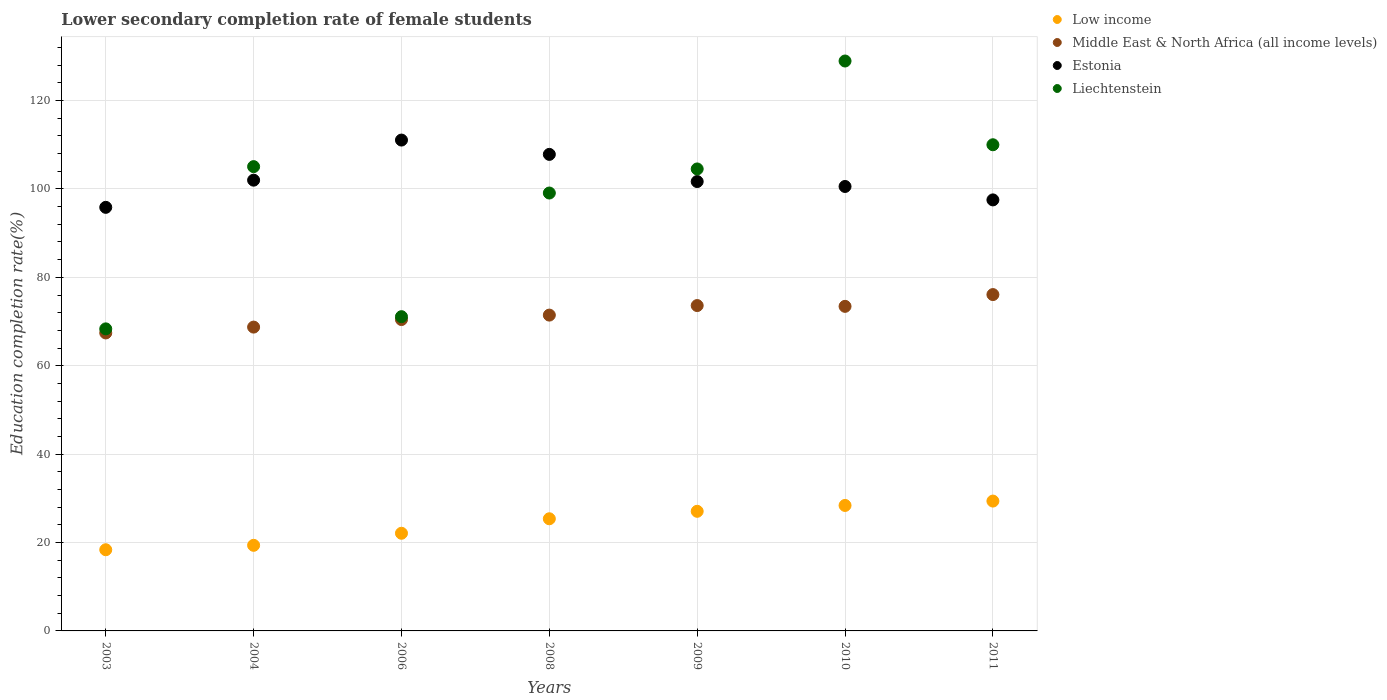Is the number of dotlines equal to the number of legend labels?
Make the answer very short. Yes. What is the lower secondary completion rate of female students in Middle East & North Africa (all income levels) in 2003?
Your response must be concise. 67.42. Across all years, what is the maximum lower secondary completion rate of female students in Liechtenstein?
Your answer should be compact. 128.95. Across all years, what is the minimum lower secondary completion rate of female students in Estonia?
Your answer should be compact. 95.84. In which year was the lower secondary completion rate of female students in Liechtenstein maximum?
Give a very brief answer. 2010. In which year was the lower secondary completion rate of female students in Liechtenstein minimum?
Keep it short and to the point. 2003. What is the total lower secondary completion rate of female students in Low income in the graph?
Provide a short and direct response. 170.04. What is the difference between the lower secondary completion rate of female students in Middle East & North Africa (all income levels) in 2006 and that in 2010?
Your response must be concise. -2.99. What is the difference between the lower secondary completion rate of female students in Low income in 2004 and the lower secondary completion rate of female students in Middle East & North Africa (all income levels) in 2008?
Provide a short and direct response. -52.09. What is the average lower secondary completion rate of female students in Liechtenstein per year?
Provide a short and direct response. 98.15. In the year 2006, what is the difference between the lower secondary completion rate of female students in Liechtenstein and lower secondary completion rate of female students in Middle East & North Africa (all income levels)?
Keep it short and to the point. 0.65. In how many years, is the lower secondary completion rate of female students in Middle East & North Africa (all income levels) greater than 56 %?
Provide a succinct answer. 7. What is the ratio of the lower secondary completion rate of female students in Liechtenstein in 2003 to that in 2010?
Provide a short and direct response. 0.53. What is the difference between the highest and the second highest lower secondary completion rate of female students in Low income?
Make the answer very short. 0.99. What is the difference between the highest and the lowest lower secondary completion rate of female students in Liechtenstein?
Offer a terse response. 60.61. Is it the case that in every year, the sum of the lower secondary completion rate of female students in Low income and lower secondary completion rate of female students in Middle East & North Africa (all income levels)  is greater than the sum of lower secondary completion rate of female students in Estonia and lower secondary completion rate of female students in Liechtenstein?
Offer a very short reply. No. Does the lower secondary completion rate of female students in Estonia monotonically increase over the years?
Your response must be concise. No. Is the lower secondary completion rate of female students in Estonia strictly greater than the lower secondary completion rate of female students in Low income over the years?
Provide a short and direct response. Yes. How many years are there in the graph?
Keep it short and to the point. 7. Does the graph contain any zero values?
Give a very brief answer. No. Does the graph contain grids?
Keep it short and to the point. Yes. How are the legend labels stacked?
Your answer should be very brief. Vertical. What is the title of the graph?
Provide a succinct answer. Lower secondary completion rate of female students. What is the label or title of the X-axis?
Make the answer very short. Years. What is the label or title of the Y-axis?
Your response must be concise. Education completion rate(%). What is the Education completion rate(%) in Low income in 2003?
Offer a terse response. 18.37. What is the Education completion rate(%) of Middle East & North Africa (all income levels) in 2003?
Offer a terse response. 67.42. What is the Education completion rate(%) in Estonia in 2003?
Your response must be concise. 95.84. What is the Education completion rate(%) in Liechtenstein in 2003?
Offer a terse response. 68.34. What is the Education completion rate(%) of Low income in 2004?
Offer a terse response. 19.37. What is the Education completion rate(%) of Middle East & North Africa (all income levels) in 2004?
Your answer should be compact. 68.74. What is the Education completion rate(%) of Estonia in 2004?
Offer a terse response. 101.99. What is the Education completion rate(%) of Liechtenstein in 2004?
Your answer should be compact. 105.05. What is the Education completion rate(%) in Low income in 2006?
Your response must be concise. 22.1. What is the Education completion rate(%) of Middle East & North Africa (all income levels) in 2006?
Provide a succinct answer. 70.45. What is the Education completion rate(%) in Estonia in 2006?
Your answer should be compact. 111.06. What is the Education completion rate(%) of Liechtenstein in 2006?
Offer a terse response. 71.1. What is the Education completion rate(%) in Low income in 2008?
Provide a short and direct response. 25.38. What is the Education completion rate(%) in Middle East & North Africa (all income levels) in 2008?
Provide a succinct answer. 71.46. What is the Education completion rate(%) of Estonia in 2008?
Ensure brevity in your answer.  107.82. What is the Education completion rate(%) of Liechtenstein in 2008?
Ensure brevity in your answer.  99.08. What is the Education completion rate(%) in Low income in 2009?
Provide a succinct answer. 27.06. What is the Education completion rate(%) in Middle East & North Africa (all income levels) in 2009?
Your answer should be compact. 73.62. What is the Education completion rate(%) of Estonia in 2009?
Ensure brevity in your answer.  101.68. What is the Education completion rate(%) of Liechtenstein in 2009?
Offer a very short reply. 104.52. What is the Education completion rate(%) of Low income in 2010?
Keep it short and to the point. 28.39. What is the Education completion rate(%) in Middle East & North Africa (all income levels) in 2010?
Your response must be concise. 73.44. What is the Education completion rate(%) in Estonia in 2010?
Provide a short and direct response. 100.56. What is the Education completion rate(%) of Liechtenstein in 2010?
Offer a terse response. 128.95. What is the Education completion rate(%) of Low income in 2011?
Give a very brief answer. 29.38. What is the Education completion rate(%) of Middle East & North Africa (all income levels) in 2011?
Offer a terse response. 76.1. What is the Education completion rate(%) of Estonia in 2011?
Keep it short and to the point. 97.52. What is the Education completion rate(%) in Liechtenstein in 2011?
Give a very brief answer. 110. Across all years, what is the maximum Education completion rate(%) of Low income?
Your response must be concise. 29.38. Across all years, what is the maximum Education completion rate(%) of Middle East & North Africa (all income levels)?
Offer a terse response. 76.1. Across all years, what is the maximum Education completion rate(%) in Estonia?
Provide a succinct answer. 111.06. Across all years, what is the maximum Education completion rate(%) in Liechtenstein?
Your response must be concise. 128.95. Across all years, what is the minimum Education completion rate(%) of Low income?
Offer a very short reply. 18.37. Across all years, what is the minimum Education completion rate(%) in Middle East & North Africa (all income levels)?
Your answer should be very brief. 67.42. Across all years, what is the minimum Education completion rate(%) of Estonia?
Your answer should be very brief. 95.84. Across all years, what is the minimum Education completion rate(%) of Liechtenstein?
Offer a very short reply. 68.34. What is the total Education completion rate(%) of Low income in the graph?
Offer a very short reply. 170.04. What is the total Education completion rate(%) of Middle East & North Africa (all income levels) in the graph?
Provide a succinct answer. 501.22. What is the total Education completion rate(%) of Estonia in the graph?
Your answer should be very brief. 716.47. What is the total Education completion rate(%) of Liechtenstein in the graph?
Offer a terse response. 687.04. What is the difference between the Education completion rate(%) in Low income in 2003 and that in 2004?
Provide a succinct answer. -1. What is the difference between the Education completion rate(%) in Middle East & North Africa (all income levels) in 2003 and that in 2004?
Give a very brief answer. -1.32. What is the difference between the Education completion rate(%) of Estonia in 2003 and that in 2004?
Offer a terse response. -6.15. What is the difference between the Education completion rate(%) in Liechtenstein in 2003 and that in 2004?
Provide a succinct answer. -36.71. What is the difference between the Education completion rate(%) in Low income in 2003 and that in 2006?
Your answer should be very brief. -3.73. What is the difference between the Education completion rate(%) in Middle East & North Africa (all income levels) in 2003 and that in 2006?
Give a very brief answer. -3.03. What is the difference between the Education completion rate(%) of Estonia in 2003 and that in 2006?
Offer a very short reply. -15.22. What is the difference between the Education completion rate(%) in Liechtenstein in 2003 and that in 2006?
Make the answer very short. -2.76. What is the difference between the Education completion rate(%) in Low income in 2003 and that in 2008?
Provide a short and direct response. -7.01. What is the difference between the Education completion rate(%) in Middle East & North Africa (all income levels) in 2003 and that in 2008?
Keep it short and to the point. -4.04. What is the difference between the Education completion rate(%) of Estonia in 2003 and that in 2008?
Offer a terse response. -11.98. What is the difference between the Education completion rate(%) of Liechtenstein in 2003 and that in 2008?
Keep it short and to the point. -30.74. What is the difference between the Education completion rate(%) in Low income in 2003 and that in 2009?
Make the answer very short. -8.7. What is the difference between the Education completion rate(%) of Middle East & North Africa (all income levels) in 2003 and that in 2009?
Give a very brief answer. -6.2. What is the difference between the Education completion rate(%) in Estonia in 2003 and that in 2009?
Offer a very short reply. -5.84. What is the difference between the Education completion rate(%) in Liechtenstein in 2003 and that in 2009?
Keep it short and to the point. -36.18. What is the difference between the Education completion rate(%) of Low income in 2003 and that in 2010?
Provide a succinct answer. -10.02. What is the difference between the Education completion rate(%) in Middle East & North Africa (all income levels) in 2003 and that in 2010?
Keep it short and to the point. -6.02. What is the difference between the Education completion rate(%) of Estonia in 2003 and that in 2010?
Offer a very short reply. -4.72. What is the difference between the Education completion rate(%) of Liechtenstein in 2003 and that in 2010?
Offer a terse response. -60.61. What is the difference between the Education completion rate(%) in Low income in 2003 and that in 2011?
Give a very brief answer. -11.01. What is the difference between the Education completion rate(%) of Middle East & North Africa (all income levels) in 2003 and that in 2011?
Your response must be concise. -8.68. What is the difference between the Education completion rate(%) in Estonia in 2003 and that in 2011?
Offer a terse response. -1.68. What is the difference between the Education completion rate(%) in Liechtenstein in 2003 and that in 2011?
Your answer should be compact. -41.66. What is the difference between the Education completion rate(%) of Low income in 2004 and that in 2006?
Your answer should be compact. -2.73. What is the difference between the Education completion rate(%) in Middle East & North Africa (all income levels) in 2004 and that in 2006?
Make the answer very short. -1.71. What is the difference between the Education completion rate(%) in Estonia in 2004 and that in 2006?
Give a very brief answer. -9.07. What is the difference between the Education completion rate(%) in Liechtenstein in 2004 and that in 2006?
Your answer should be very brief. 33.95. What is the difference between the Education completion rate(%) of Low income in 2004 and that in 2008?
Make the answer very short. -6.01. What is the difference between the Education completion rate(%) of Middle East & North Africa (all income levels) in 2004 and that in 2008?
Provide a succinct answer. -2.71. What is the difference between the Education completion rate(%) of Estonia in 2004 and that in 2008?
Provide a succinct answer. -5.84. What is the difference between the Education completion rate(%) of Liechtenstein in 2004 and that in 2008?
Your answer should be very brief. 5.97. What is the difference between the Education completion rate(%) in Low income in 2004 and that in 2009?
Ensure brevity in your answer.  -7.7. What is the difference between the Education completion rate(%) in Middle East & North Africa (all income levels) in 2004 and that in 2009?
Your answer should be compact. -4.87. What is the difference between the Education completion rate(%) of Estonia in 2004 and that in 2009?
Keep it short and to the point. 0.31. What is the difference between the Education completion rate(%) in Liechtenstein in 2004 and that in 2009?
Your answer should be very brief. 0.53. What is the difference between the Education completion rate(%) of Low income in 2004 and that in 2010?
Offer a very short reply. -9.02. What is the difference between the Education completion rate(%) of Middle East & North Africa (all income levels) in 2004 and that in 2010?
Offer a very short reply. -4.69. What is the difference between the Education completion rate(%) in Estonia in 2004 and that in 2010?
Offer a very short reply. 1.43. What is the difference between the Education completion rate(%) in Liechtenstein in 2004 and that in 2010?
Offer a very short reply. -23.9. What is the difference between the Education completion rate(%) in Low income in 2004 and that in 2011?
Make the answer very short. -10.01. What is the difference between the Education completion rate(%) of Middle East & North Africa (all income levels) in 2004 and that in 2011?
Give a very brief answer. -7.36. What is the difference between the Education completion rate(%) in Estonia in 2004 and that in 2011?
Offer a very short reply. 4.46. What is the difference between the Education completion rate(%) of Liechtenstein in 2004 and that in 2011?
Offer a very short reply. -4.95. What is the difference between the Education completion rate(%) of Low income in 2006 and that in 2008?
Keep it short and to the point. -3.28. What is the difference between the Education completion rate(%) in Middle East & North Africa (all income levels) in 2006 and that in 2008?
Give a very brief answer. -1.01. What is the difference between the Education completion rate(%) of Estonia in 2006 and that in 2008?
Your answer should be compact. 3.24. What is the difference between the Education completion rate(%) of Liechtenstein in 2006 and that in 2008?
Provide a succinct answer. -27.98. What is the difference between the Education completion rate(%) of Low income in 2006 and that in 2009?
Give a very brief answer. -4.97. What is the difference between the Education completion rate(%) in Middle East & North Africa (all income levels) in 2006 and that in 2009?
Your answer should be compact. -3.17. What is the difference between the Education completion rate(%) in Estonia in 2006 and that in 2009?
Make the answer very short. 9.39. What is the difference between the Education completion rate(%) of Liechtenstein in 2006 and that in 2009?
Your response must be concise. -33.42. What is the difference between the Education completion rate(%) in Low income in 2006 and that in 2010?
Offer a terse response. -6.29. What is the difference between the Education completion rate(%) in Middle East & North Africa (all income levels) in 2006 and that in 2010?
Make the answer very short. -2.99. What is the difference between the Education completion rate(%) in Estonia in 2006 and that in 2010?
Your response must be concise. 10.5. What is the difference between the Education completion rate(%) in Liechtenstein in 2006 and that in 2010?
Make the answer very short. -57.85. What is the difference between the Education completion rate(%) of Low income in 2006 and that in 2011?
Make the answer very short. -7.28. What is the difference between the Education completion rate(%) in Middle East & North Africa (all income levels) in 2006 and that in 2011?
Provide a short and direct response. -5.65. What is the difference between the Education completion rate(%) of Estonia in 2006 and that in 2011?
Offer a very short reply. 13.54. What is the difference between the Education completion rate(%) in Liechtenstein in 2006 and that in 2011?
Offer a terse response. -38.9. What is the difference between the Education completion rate(%) in Low income in 2008 and that in 2009?
Give a very brief answer. -1.69. What is the difference between the Education completion rate(%) of Middle East & North Africa (all income levels) in 2008 and that in 2009?
Keep it short and to the point. -2.16. What is the difference between the Education completion rate(%) of Estonia in 2008 and that in 2009?
Give a very brief answer. 6.15. What is the difference between the Education completion rate(%) in Liechtenstein in 2008 and that in 2009?
Provide a succinct answer. -5.45. What is the difference between the Education completion rate(%) of Low income in 2008 and that in 2010?
Your answer should be very brief. -3.01. What is the difference between the Education completion rate(%) in Middle East & North Africa (all income levels) in 2008 and that in 2010?
Your response must be concise. -1.98. What is the difference between the Education completion rate(%) in Estonia in 2008 and that in 2010?
Provide a succinct answer. 7.26. What is the difference between the Education completion rate(%) of Liechtenstein in 2008 and that in 2010?
Give a very brief answer. -29.87. What is the difference between the Education completion rate(%) of Low income in 2008 and that in 2011?
Make the answer very short. -4. What is the difference between the Education completion rate(%) of Middle East & North Africa (all income levels) in 2008 and that in 2011?
Keep it short and to the point. -4.64. What is the difference between the Education completion rate(%) in Estonia in 2008 and that in 2011?
Provide a succinct answer. 10.3. What is the difference between the Education completion rate(%) of Liechtenstein in 2008 and that in 2011?
Ensure brevity in your answer.  -10.92. What is the difference between the Education completion rate(%) in Low income in 2009 and that in 2010?
Your answer should be very brief. -1.33. What is the difference between the Education completion rate(%) in Middle East & North Africa (all income levels) in 2009 and that in 2010?
Give a very brief answer. 0.18. What is the difference between the Education completion rate(%) of Estonia in 2009 and that in 2010?
Give a very brief answer. 1.12. What is the difference between the Education completion rate(%) of Liechtenstein in 2009 and that in 2010?
Keep it short and to the point. -24.42. What is the difference between the Education completion rate(%) in Low income in 2009 and that in 2011?
Your response must be concise. -2.31. What is the difference between the Education completion rate(%) of Middle East & North Africa (all income levels) in 2009 and that in 2011?
Offer a terse response. -2.48. What is the difference between the Education completion rate(%) of Estonia in 2009 and that in 2011?
Your answer should be compact. 4.15. What is the difference between the Education completion rate(%) of Liechtenstein in 2009 and that in 2011?
Your response must be concise. -5.48. What is the difference between the Education completion rate(%) of Low income in 2010 and that in 2011?
Your answer should be very brief. -0.99. What is the difference between the Education completion rate(%) in Middle East & North Africa (all income levels) in 2010 and that in 2011?
Keep it short and to the point. -2.66. What is the difference between the Education completion rate(%) of Estonia in 2010 and that in 2011?
Give a very brief answer. 3.04. What is the difference between the Education completion rate(%) in Liechtenstein in 2010 and that in 2011?
Give a very brief answer. 18.95. What is the difference between the Education completion rate(%) in Low income in 2003 and the Education completion rate(%) in Middle East & North Africa (all income levels) in 2004?
Offer a terse response. -50.37. What is the difference between the Education completion rate(%) of Low income in 2003 and the Education completion rate(%) of Estonia in 2004?
Your response must be concise. -83.62. What is the difference between the Education completion rate(%) of Low income in 2003 and the Education completion rate(%) of Liechtenstein in 2004?
Keep it short and to the point. -86.68. What is the difference between the Education completion rate(%) in Middle East & North Africa (all income levels) in 2003 and the Education completion rate(%) in Estonia in 2004?
Ensure brevity in your answer.  -34.57. What is the difference between the Education completion rate(%) in Middle East & North Africa (all income levels) in 2003 and the Education completion rate(%) in Liechtenstein in 2004?
Your response must be concise. -37.63. What is the difference between the Education completion rate(%) of Estonia in 2003 and the Education completion rate(%) of Liechtenstein in 2004?
Offer a terse response. -9.21. What is the difference between the Education completion rate(%) of Low income in 2003 and the Education completion rate(%) of Middle East & North Africa (all income levels) in 2006?
Your response must be concise. -52.08. What is the difference between the Education completion rate(%) of Low income in 2003 and the Education completion rate(%) of Estonia in 2006?
Your answer should be compact. -92.69. What is the difference between the Education completion rate(%) in Low income in 2003 and the Education completion rate(%) in Liechtenstein in 2006?
Provide a succinct answer. -52.73. What is the difference between the Education completion rate(%) in Middle East & North Africa (all income levels) in 2003 and the Education completion rate(%) in Estonia in 2006?
Ensure brevity in your answer.  -43.64. What is the difference between the Education completion rate(%) in Middle East & North Africa (all income levels) in 2003 and the Education completion rate(%) in Liechtenstein in 2006?
Make the answer very short. -3.68. What is the difference between the Education completion rate(%) of Estonia in 2003 and the Education completion rate(%) of Liechtenstein in 2006?
Your response must be concise. 24.74. What is the difference between the Education completion rate(%) in Low income in 2003 and the Education completion rate(%) in Middle East & North Africa (all income levels) in 2008?
Offer a terse response. -53.09. What is the difference between the Education completion rate(%) of Low income in 2003 and the Education completion rate(%) of Estonia in 2008?
Keep it short and to the point. -89.45. What is the difference between the Education completion rate(%) in Low income in 2003 and the Education completion rate(%) in Liechtenstein in 2008?
Offer a very short reply. -80.71. What is the difference between the Education completion rate(%) of Middle East & North Africa (all income levels) in 2003 and the Education completion rate(%) of Estonia in 2008?
Your answer should be compact. -40.4. What is the difference between the Education completion rate(%) in Middle East & North Africa (all income levels) in 2003 and the Education completion rate(%) in Liechtenstein in 2008?
Offer a very short reply. -31.66. What is the difference between the Education completion rate(%) of Estonia in 2003 and the Education completion rate(%) of Liechtenstein in 2008?
Give a very brief answer. -3.24. What is the difference between the Education completion rate(%) of Low income in 2003 and the Education completion rate(%) of Middle East & North Africa (all income levels) in 2009?
Ensure brevity in your answer.  -55.25. What is the difference between the Education completion rate(%) in Low income in 2003 and the Education completion rate(%) in Estonia in 2009?
Make the answer very short. -83.31. What is the difference between the Education completion rate(%) in Low income in 2003 and the Education completion rate(%) in Liechtenstein in 2009?
Give a very brief answer. -86.16. What is the difference between the Education completion rate(%) of Middle East & North Africa (all income levels) in 2003 and the Education completion rate(%) of Estonia in 2009?
Offer a terse response. -34.26. What is the difference between the Education completion rate(%) of Middle East & North Africa (all income levels) in 2003 and the Education completion rate(%) of Liechtenstein in 2009?
Provide a short and direct response. -37.11. What is the difference between the Education completion rate(%) of Estonia in 2003 and the Education completion rate(%) of Liechtenstein in 2009?
Provide a short and direct response. -8.69. What is the difference between the Education completion rate(%) of Low income in 2003 and the Education completion rate(%) of Middle East & North Africa (all income levels) in 2010?
Offer a very short reply. -55.07. What is the difference between the Education completion rate(%) of Low income in 2003 and the Education completion rate(%) of Estonia in 2010?
Make the answer very short. -82.19. What is the difference between the Education completion rate(%) in Low income in 2003 and the Education completion rate(%) in Liechtenstein in 2010?
Your response must be concise. -110.58. What is the difference between the Education completion rate(%) of Middle East & North Africa (all income levels) in 2003 and the Education completion rate(%) of Estonia in 2010?
Your answer should be compact. -33.14. What is the difference between the Education completion rate(%) in Middle East & North Africa (all income levels) in 2003 and the Education completion rate(%) in Liechtenstein in 2010?
Offer a very short reply. -61.53. What is the difference between the Education completion rate(%) in Estonia in 2003 and the Education completion rate(%) in Liechtenstein in 2010?
Offer a terse response. -33.11. What is the difference between the Education completion rate(%) of Low income in 2003 and the Education completion rate(%) of Middle East & North Africa (all income levels) in 2011?
Give a very brief answer. -57.73. What is the difference between the Education completion rate(%) in Low income in 2003 and the Education completion rate(%) in Estonia in 2011?
Keep it short and to the point. -79.15. What is the difference between the Education completion rate(%) in Low income in 2003 and the Education completion rate(%) in Liechtenstein in 2011?
Offer a very short reply. -91.63. What is the difference between the Education completion rate(%) of Middle East & North Africa (all income levels) in 2003 and the Education completion rate(%) of Estonia in 2011?
Provide a succinct answer. -30.1. What is the difference between the Education completion rate(%) in Middle East & North Africa (all income levels) in 2003 and the Education completion rate(%) in Liechtenstein in 2011?
Offer a terse response. -42.58. What is the difference between the Education completion rate(%) in Estonia in 2003 and the Education completion rate(%) in Liechtenstein in 2011?
Your response must be concise. -14.16. What is the difference between the Education completion rate(%) in Low income in 2004 and the Education completion rate(%) in Middle East & North Africa (all income levels) in 2006?
Make the answer very short. -51.08. What is the difference between the Education completion rate(%) in Low income in 2004 and the Education completion rate(%) in Estonia in 2006?
Offer a very short reply. -91.69. What is the difference between the Education completion rate(%) in Low income in 2004 and the Education completion rate(%) in Liechtenstein in 2006?
Provide a short and direct response. -51.73. What is the difference between the Education completion rate(%) of Middle East & North Africa (all income levels) in 2004 and the Education completion rate(%) of Estonia in 2006?
Provide a short and direct response. -42.32. What is the difference between the Education completion rate(%) in Middle East & North Africa (all income levels) in 2004 and the Education completion rate(%) in Liechtenstein in 2006?
Provide a short and direct response. -2.36. What is the difference between the Education completion rate(%) of Estonia in 2004 and the Education completion rate(%) of Liechtenstein in 2006?
Keep it short and to the point. 30.89. What is the difference between the Education completion rate(%) of Low income in 2004 and the Education completion rate(%) of Middle East & North Africa (all income levels) in 2008?
Your answer should be compact. -52.09. What is the difference between the Education completion rate(%) in Low income in 2004 and the Education completion rate(%) in Estonia in 2008?
Ensure brevity in your answer.  -88.45. What is the difference between the Education completion rate(%) of Low income in 2004 and the Education completion rate(%) of Liechtenstein in 2008?
Give a very brief answer. -79.71. What is the difference between the Education completion rate(%) of Middle East & North Africa (all income levels) in 2004 and the Education completion rate(%) of Estonia in 2008?
Your response must be concise. -39.08. What is the difference between the Education completion rate(%) of Middle East & North Africa (all income levels) in 2004 and the Education completion rate(%) of Liechtenstein in 2008?
Provide a short and direct response. -30.34. What is the difference between the Education completion rate(%) in Estonia in 2004 and the Education completion rate(%) in Liechtenstein in 2008?
Provide a short and direct response. 2.91. What is the difference between the Education completion rate(%) of Low income in 2004 and the Education completion rate(%) of Middle East & North Africa (all income levels) in 2009?
Ensure brevity in your answer.  -54.25. What is the difference between the Education completion rate(%) in Low income in 2004 and the Education completion rate(%) in Estonia in 2009?
Your answer should be compact. -82.31. What is the difference between the Education completion rate(%) of Low income in 2004 and the Education completion rate(%) of Liechtenstein in 2009?
Provide a short and direct response. -85.16. What is the difference between the Education completion rate(%) of Middle East & North Africa (all income levels) in 2004 and the Education completion rate(%) of Estonia in 2009?
Offer a very short reply. -32.93. What is the difference between the Education completion rate(%) in Middle East & North Africa (all income levels) in 2004 and the Education completion rate(%) in Liechtenstein in 2009?
Ensure brevity in your answer.  -35.78. What is the difference between the Education completion rate(%) of Estonia in 2004 and the Education completion rate(%) of Liechtenstein in 2009?
Make the answer very short. -2.54. What is the difference between the Education completion rate(%) in Low income in 2004 and the Education completion rate(%) in Middle East & North Africa (all income levels) in 2010?
Provide a succinct answer. -54.07. What is the difference between the Education completion rate(%) of Low income in 2004 and the Education completion rate(%) of Estonia in 2010?
Your answer should be very brief. -81.19. What is the difference between the Education completion rate(%) of Low income in 2004 and the Education completion rate(%) of Liechtenstein in 2010?
Your response must be concise. -109.58. What is the difference between the Education completion rate(%) of Middle East & North Africa (all income levels) in 2004 and the Education completion rate(%) of Estonia in 2010?
Make the answer very short. -31.82. What is the difference between the Education completion rate(%) of Middle East & North Africa (all income levels) in 2004 and the Education completion rate(%) of Liechtenstein in 2010?
Your response must be concise. -60.21. What is the difference between the Education completion rate(%) of Estonia in 2004 and the Education completion rate(%) of Liechtenstein in 2010?
Provide a short and direct response. -26.96. What is the difference between the Education completion rate(%) of Low income in 2004 and the Education completion rate(%) of Middle East & North Africa (all income levels) in 2011?
Offer a very short reply. -56.73. What is the difference between the Education completion rate(%) in Low income in 2004 and the Education completion rate(%) in Estonia in 2011?
Keep it short and to the point. -78.15. What is the difference between the Education completion rate(%) of Low income in 2004 and the Education completion rate(%) of Liechtenstein in 2011?
Your answer should be compact. -90.63. What is the difference between the Education completion rate(%) of Middle East & North Africa (all income levels) in 2004 and the Education completion rate(%) of Estonia in 2011?
Provide a succinct answer. -28.78. What is the difference between the Education completion rate(%) of Middle East & North Africa (all income levels) in 2004 and the Education completion rate(%) of Liechtenstein in 2011?
Your answer should be compact. -41.26. What is the difference between the Education completion rate(%) in Estonia in 2004 and the Education completion rate(%) in Liechtenstein in 2011?
Make the answer very short. -8.01. What is the difference between the Education completion rate(%) in Low income in 2006 and the Education completion rate(%) in Middle East & North Africa (all income levels) in 2008?
Offer a very short reply. -49.36. What is the difference between the Education completion rate(%) in Low income in 2006 and the Education completion rate(%) in Estonia in 2008?
Your response must be concise. -85.73. What is the difference between the Education completion rate(%) in Low income in 2006 and the Education completion rate(%) in Liechtenstein in 2008?
Offer a terse response. -76.98. What is the difference between the Education completion rate(%) in Middle East & North Africa (all income levels) in 2006 and the Education completion rate(%) in Estonia in 2008?
Provide a succinct answer. -37.37. What is the difference between the Education completion rate(%) in Middle East & North Africa (all income levels) in 2006 and the Education completion rate(%) in Liechtenstein in 2008?
Your answer should be compact. -28.63. What is the difference between the Education completion rate(%) of Estonia in 2006 and the Education completion rate(%) of Liechtenstein in 2008?
Keep it short and to the point. 11.98. What is the difference between the Education completion rate(%) of Low income in 2006 and the Education completion rate(%) of Middle East & North Africa (all income levels) in 2009?
Your answer should be very brief. -51.52. What is the difference between the Education completion rate(%) in Low income in 2006 and the Education completion rate(%) in Estonia in 2009?
Your response must be concise. -79.58. What is the difference between the Education completion rate(%) of Low income in 2006 and the Education completion rate(%) of Liechtenstein in 2009?
Your answer should be very brief. -82.43. What is the difference between the Education completion rate(%) of Middle East & North Africa (all income levels) in 2006 and the Education completion rate(%) of Estonia in 2009?
Make the answer very short. -31.23. What is the difference between the Education completion rate(%) in Middle East & North Africa (all income levels) in 2006 and the Education completion rate(%) in Liechtenstein in 2009?
Offer a terse response. -34.07. What is the difference between the Education completion rate(%) in Estonia in 2006 and the Education completion rate(%) in Liechtenstein in 2009?
Offer a very short reply. 6.54. What is the difference between the Education completion rate(%) of Low income in 2006 and the Education completion rate(%) of Middle East & North Africa (all income levels) in 2010?
Provide a succinct answer. -51.34. What is the difference between the Education completion rate(%) in Low income in 2006 and the Education completion rate(%) in Estonia in 2010?
Ensure brevity in your answer.  -78.46. What is the difference between the Education completion rate(%) of Low income in 2006 and the Education completion rate(%) of Liechtenstein in 2010?
Ensure brevity in your answer.  -106.85. What is the difference between the Education completion rate(%) of Middle East & North Africa (all income levels) in 2006 and the Education completion rate(%) of Estonia in 2010?
Give a very brief answer. -30.11. What is the difference between the Education completion rate(%) of Middle East & North Africa (all income levels) in 2006 and the Education completion rate(%) of Liechtenstein in 2010?
Offer a terse response. -58.5. What is the difference between the Education completion rate(%) of Estonia in 2006 and the Education completion rate(%) of Liechtenstein in 2010?
Keep it short and to the point. -17.89. What is the difference between the Education completion rate(%) in Low income in 2006 and the Education completion rate(%) in Middle East & North Africa (all income levels) in 2011?
Make the answer very short. -54. What is the difference between the Education completion rate(%) in Low income in 2006 and the Education completion rate(%) in Estonia in 2011?
Your answer should be very brief. -75.43. What is the difference between the Education completion rate(%) of Low income in 2006 and the Education completion rate(%) of Liechtenstein in 2011?
Offer a very short reply. -87.9. What is the difference between the Education completion rate(%) of Middle East & North Africa (all income levels) in 2006 and the Education completion rate(%) of Estonia in 2011?
Offer a terse response. -27.07. What is the difference between the Education completion rate(%) of Middle East & North Africa (all income levels) in 2006 and the Education completion rate(%) of Liechtenstein in 2011?
Keep it short and to the point. -39.55. What is the difference between the Education completion rate(%) in Estonia in 2006 and the Education completion rate(%) in Liechtenstein in 2011?
Ensure brevity in your answer.  1.06. What is the difference between the Education completion rate(%) of Low income in 2008 and the Education completion rate(%) of Middle East & North Africa (all income levels) in 2009?
Offer a very short reply. -48.24. What is the difference between the Education completion rate(%) in Low income in 2008 and the Education completion rate(%) in Estonia in 2009?
Keep it short and to the point. -76.3. What is the difference between the Education completion rate(%) of Low income in 2008 and the Education completion rate(%) of Liechtenstein in 2009?
Keep it short and to the point. -79.15. What is the difference between the Education completion rate(%) of Middle East & North Africa (all income levels) in 2008 and the Education completion rate(%) of Estonia in 2009?
Your answer should be very brief. -30.22. What is the difference between the Education completion rate(%) of Middle East & North Africa (all income levels) in 2008 and the Education completion rate(%) of Liechtenstein in 2009?
Your response must be concise. -33.07. What is the difference between the Education completion rate(%) of Estonia in 2008 and the Education completion rate(%) of Liechtenstein in 2009?
Your answer should be very brief. 3.3. What is the difference between the Education completion rate(%) in Low income in 2008 and the Education completion rate(%) in Middle East & North Africa (all income levels) in 2010?
Provide a short and direct response. -48.06. What is the difference between the Education completion rate(%) of Low income in 2008 and the Education completion rate(%) of Estonia in 2010?
Your answer should be compact. -75.18. What is the difference between the Education completion rate(%) in Low income in 2008 and the Education completion rate(%) in Liechtenstein in 2010?
Your answer should be compact. -103.57. What is the difference between the Education completion rate(%) of Middle East & North Africa (all income levels) in 2008 and the Education completion rate(%) of Estonia in 2010?
Provide a short and direct response. -29.1. What is the difference between the Education completion rate(%) of Middle East & North Africa (all income levels) in 2008 and the Education completion rate(%) of Liechtenstein in 2010?
Provide a short and direct response. -57.49. What is the difference between the Education completion rate(%) in Estonia in 2008 and the Education completion rate(%) in Liechtenstein in 2010?
Provide a short and direct response. -21.13. What is the difference between the Education completion rate(%) in Low income in 2008 and the Education completion rate(%) in Middle East & North Africa (all income levels) in 2011?
Provide a short and direct response. -50.72. What is the difference between the Education completion rate(%) in Low income in 2008 and the Education completion rate(%) in Estonia in 2011?
Your response must be concise. -72.15. What is the difference between the Education completion rate(%) of Low income in 2008 and the Education completion rate(%) of Liechtenstein in 2011?
Offer a terse response. -84.62. What is the difference between the Education completion rate(%) in Middle East & North Africa (all income levels) in 2008 and the Education completion rate(%) in Estonia in 2011?
Offer a very short reply. -26.07. What is the difference between the Education completion rate(%) in Middle East & North Africa (all income levels) in 2008 and the Education completion rate(%) in Liechtenstein in 2011?
Your response must be concise. -38.54. What is the difference between the Education completion rate(%) of Estonia in 2008 and the Education completion rate(%) of Liechtenstein in 2011?
Provide a short and direct response. -2.18. What is the difference between the Education completion rate(%) of Low income in 2009 and the Education completion rate(%) of Middle East & North Africa (all income levels) in 2010?
Make the answer very short. -46.37. What is the difference between the Education completion rate(%) in Low income in 2009 and the Education completion rate(%) in Estonia in 2010?
Offer a terse response. -73.5. What is the difference between the Education completion rate(%) in Low income in 2009 and the Education completion rate(%) in Liechtenstein in 2010?
Provide a succinct answer. -101.88. What is the difference between the Education completion rate(%) in Middle East & North Africa (all income levels) in 2009 and the Education completion rate(%) in Estonia in 2010?
Your response must be concise. -26.94. What is the difference between the Education completion rate(%) in Middle East & North Africa (all income levels) in 2009 and the Education completion rate(%) in Liechtenstein in 2010?
Provide a short and direct response. -55.33. What is the difference between the Education completion rate(%) in Estonia in 2009 and the Education completion rate(%) in Liechtenstein in 2010?
Keep it short and to the point. -27.27. What is the difference between the Education completion rate(%) of Low income in 2009 and the Education completion rate(%) of Middle East & North Africa (all income levels) in 2011?
Make the answer very short. -49.04. What is the difference between the Education completion rate(%) in Low income in 2009 and the Education completion rate(%) in Estonia in 2011?
Your answer should be very brief. -70.46. What is the difference between the Education completion rate(%) of Low income in 2009 and the Education completion rate(%) of Liechtenstein in 2011?
Ensure brevity in your answer.  -82.94. What is the difference between the Education completion rate(%) of Middle East & North Africa (all income levels) in 2009 and the Education completion rate(%) of Estonia in 2011?
Make the answer very short. -23.91. What is the difference between the Education completion rate(%) of Middle East & North Africa (all income levels) in 2009 and the Education completion rate(%) of Liechtenstein in 2011?
Your response must be concise. -36.38. What is the difference between the Education completion rate(%) of Estonia in 2009 and the Education completion rate(%) of Liechtenstein in 2011?
Offer a terse response. -8.32. What is the difference between the Education completion rate(%) in Low income in 2010 and the Education completion rate(%) in Middle East & North Africa (all income levels) in 2011?
Make the answer very short. -47.71. What is the difference between the Education completion rate(%) of Low income in 2010 and the Education completion rate(%) of Estonia in 2011?
Keep it short and to the point. -69.13. What is the difference between the Education completion rate(%) in Low income in 2010 and the Education completion rate(%) in Liechtenstein in 2011?
Your answer should be very brief. -81.61. What is the difference between the Education completion rate(%) of Middle East & North Africa (all income levels) in 2010 and the Education completion rate(%) of Estonia in 2011?
Make the answer very short. -24.09. What is the difference between the Education completion rate(%) in Middle East & North Africa (all income levels) in 2010 and the Education completion rate(%) in Liechtenstein in 2011?
Provide a short and direct response. -36.56. What is the difference between the Education completion rate(%) in Estonia in 2010 and the Education completion rate(%) in Liechtenstein in 2011?
Your response must be concise. -9.44. What is the average Education completion rate(%) in Low income per year?
Offer a terse response. 24.29. What is the average Education completion rate(%) in Middle East & North Africa (all income levels) per year?
Keep it short and to the point. 71.6. What is the average Education completion rate(%) in Estonia per year?
Provide a succinct answer. 102.35. What is the average Education completion rate(%) in Liechtenstein per year?
Give a very brief answer. 98.15. In the year 2003, what is the difference between the Education completion rate(%) in Low income and Education completion rate(%) in Middle East & North Africa (all income levels)?
Provide a short and direct response. -49.05. In the year 2003, what is the difference between the Education completion rate(%) in Low income and Education completion rate(%) in Estonia?
Keep it short and to the point. -77.47. In the year 2003, what is the difference between the Education completion rate(%) of Low income and Education completion rate(%) of Liechtenstein?
Offer a very short reply. -49.97. In the year 2003, what is the difference between the Education completion rate(%) in Middle East & North Africa (all income levels) and Education completion rate(%) in Estonia?
Provide a short and direct response. -28.42. In the year 2003, what is the difference between the Education completion rate(%) of Middle East & North Africa (all income levels) and Education completion rate(%) of Liechtenstein?
Make the answer very short. -0.92. In the year 2003, what is the difference between the Education completion rate(%) of Estonia and Education completion rate(%) of Liechtenstein?
Provide a short and direct response. 27.5. In the year 2004, what is the difference between the Education completion rate(%) of Low income and Education completion rate(%) of Middle East & North Africa (all income levels)?
Offer a very short reply. -49.37. In the year 2004, what is the difference between the Education completion rate(%) in Low income and Education completion rate(%) in Estonia?
Your answer should be very brief. -82.62. In the year 2004, what is the difference between the Education completion rate(%) in Low income and Education completion rate(%) in Liechtenstein?
Make the answer very short. -85.68. In the year 2004, what is the difference between the Education completion rate(%) in Middle East & North Africa (all income levels) and Education completion rate(%) in Estonia?
Your response must be concise. -33.24. In the year 2004, what is the difference between the Education completion rate(%) of Middle East & North Africa (all income levels) and Education completion rate(%) of Liechtenstein?
Keep it short and to the point. -36.31. In the year 2004, what is the difference between the Education completion rate(%) in Estonia and Education completion rate(%) in Liechtenstein?
Make the answer very short. -3.06. In the year 2006, what is the difference between the Education completion rate(%) of Low income and Education completion rate(%) of Middle East & North Africa (all income levels)?
Give a very brief answer. -48.35. In the year 2006, what is the difference between the Education completion rate(%) in Low income and Education completion rate(%) in Estonia?
Your answer should be very brief. -88.96. In the year 2006, what is the difference between the Education completion rate(%) in Low income and Education completion rate(%) in Liechtenstein?
Your answer should be compact. -49. In the year 2006, what is the difference between the Education completion rate(%) of Middle East & North Africa (all income levels) and Education completion rate(%) of Estonia?
Provide a short and direct response. -40.61. In the year 2006, what is the difference between the Education completion rate(%) in Middle East & North Africa (all income levels) and Education completion rate(%) in Liechtenstein?
Provide a short and direct response. -0.65. In the year 2006, what is the difference between the Education completion rate(%) of Estonia and Education completion rate(%) of Liechtenstein?
Ensure brevity in your answer.  39.96. In the year 2008, what is the difference between the Education completion rate(%) in Low income and Education completion rate(%) in Middle East & North Africa (all income levels)?
Offer a terse response. -46.08. In the year 2008, what is the difference between the Education completion rate(%) in Low income and Education completion rate(%) in Estonia?
Provide a succinct answer. -82.45. In the year 2008, what is the difference between the Education completion rate(%) in Low income and Education completion rate(%) in Liechtenstein?
Your response must be concise. -73.7. In the year 2008, what is the difference between the Education completion rate(%) in Middle East & North Africa (all income levels) and Education completion rate(%) in Estonia?
Offer a very short reply. -36.37. In the year 2008, what is the difference between the Education completion rate(%) in Middle East & North Africa (all income levels) and Education completion rate(%) in Liechtenstein?
Your answer should be compact. -27.62. In the year 2008, what is the difference between the Education completion rate(%) of Estonia and Education completion rate(%) of Liechtenstein?
Make the answer very short. 8.74. In the year 2009, what is the difference between the Education completion rate(%) of Low income and Education completion rate(%) of Middle East & North Africa (all income levels)?
Make the answer very short. -46.55. In the year 2009, what is the difference between the Education completion rate(%) of Low income and Education completion rate(%) of Estonia?
Make the answer very short. -74.61. In the year 2009, what is the difference between the Education completion rate(%) of Low income and Education completion rate(%) of Liechtenstein?
Provide a succinct answer. -77.46. In the year 2009, what is the difference between the Education completion rate(%) in Middle East & North Africa (all income levels) and Education completion rate(%) in Estonia?
Your response must be concise. -28.06. In the year 2009, what is the difference between the Education completion rate(%) of Middle East & North Africa (all income levels) and Education completion rate(%) of Liechtenstein?
Your response must be concise. -30.91. In the year 2009, what is the difference between the Education completion rate(%) of Estonia and Education completion rate(%) of Liechtenstein?
Make the answer very short. -2.85. In the year 2010, what is the difference between the Education completion rate(%) of Low income and Education completion rate(%) of Middle East & North Africa (all income levels)?
Make the answer very short. -45.05. In the year 2010, what is the difference between the Education completion rate(%) in Low income and Education completion rate(%) in Estonia?
Your answer should be compact. -72.17. In the year 2010, what is the difference between the Education completion rate(%) in Low income and Education completion rate(%) in Liechtenstein?
Make the answer very short. -100.56. In the year 2010, what is the difference between the Education completion rate(%) in Middle East & North Africa (all income levels) and Education completion rate(%) in Estonia?
Your answer should be very brief. -27.12. In the year 2010, what is the difference between the Education completion rate(%) of Middle East & North Africa (all income levels) and Education completion rate(%) of Liechtenstein?
Provide a short and direct response. -55.51. In the year 2010, what is the difference between the Education completion rate(%) of Estonia and Education completion rate(%) of Liechtenstein?
Provide a succinct answer. -28.39. In the year 2011, what is the difference between the Education completion rate(%) of Low income and Education completion rate(%) of Middle East & North Africa (all income levels)?
Offer a very short reply. -46.72. In the year 2011, what is the difference between the Education completion rate(%) in Low income and Education completion rate(%) in Estonia?
Offer a terse response. -68.14. In the year 2011, what is the difference between the Education completion rate(%) in Low income and Education completion rate(%) in Liechtenstein?
Make the answer very short. -80.62. In the year 2011, what is the difference between the Education completion rate(%) in Middle East & North Africa (all income levels) and Education completion rate(%) in Estonia?
Your response must be concise. -21.42. In the year 2011, what is the difference between the Education completion rate(%) in Middle East & North Africa (all income levels) and Education completion rate(%) in Liechtenstein?
Offer a very short reply. -33.9. In the year 2011, what is the difference between the Education completion rate(%) of Estonia and Education completion rate(%) of Liechtenstein?
Your answer should be compact. -12.48. What is the ratio of the Education completion rate(%) of Low income in 2003 to that in 2004?
Your response must be concise. 0.95. What is the ratio of the Education completion rate(%) in Middle East & North Africa (all income levels) in 2003 to that in 2004?
Your answer should be compact. 0.98. What is the ratio of the Education completion rate(%) of Estonia in 2003 to that in 2004?
Your answer should be compact. 0.94. What is the ratio of the Education completion rate(%) in Liechtenstein in 2003 to that in 2004?
Offer a terse response. 0.65. What is the ratio of the Education completion rate(%) of Low income in 2003 to that in 2006?
Provide a short and direct response. 0.83. What is the ratio of the Education completion rate(%) of Estonia in 2003 to that in 2006?
Your response must be concise. 0.86. What is the ratio of the Education completion rate(%) of Liechtenstein in 2003 to that in 2006?
Provide a short and direct response. 0.96. What is the ratio of the Education completion rate(%) of Low income in 2003 to that in 2008?
Your answer should be compact. 0.72. What is the ratio of the Education completion rate(%) of Middle East & North Africa (all income levels) in 2003 to that in 2008?
Your response must be concise. 0.94. What is the ratio of the Education completion rate(%) in Estonia in 2003 to that in 2008?
Ensure brevity in your answer.  0.89. What is the ratio of the Education completion rate(%) in Liechtenstein in 2003 to that in 2008?
Provide a succinct answer. 0.69. What is the ratio of the Education completion rate(%) of Low income in 2003 to that in 2009?
Keep it short and to the point. 0.68. What is the ratio of the Education completion rate(%) of Middle East & North Africa (all income levels) in 2003 to that in 2009?
Offer a very short reply. 0.92. What is the ratio of the Education completion rate(%) of Estonia in 2003 to that in 2009?
Provide a short and direct response. 0.94. What is the ratio of the Education completion rate(%) in Liechtenstein in 2003 to that in 2009?
Your answer should be compact. 0.65. What is the ratio of the Education completion rate(%) of Low income in 2003 to that in 2010?
Offer a very short reply. 0.65. What is the ratio of the Education completion rate(%) in Middle East & North Africa (all income levels) in 2003 to that in 2010?
Provide a succinct answer. 0.92. What is the ratio of the Education completion rate(%) in Estonia in 2003 to that in 2010?
Provide a succinct answer. 0.95. What is the ratio of the Education completion rate(%) of Liechtenstein in 2003 to that in 2010?
Provide a succinct answer. 0.53. What is the ratio of the Education completion rate(%) in Low income in 2003 to that in 2011?
Give a very brief answer. 0.63. What is the ratio of the Education completion rate(%) of Middle East & North Africa (all income levels) in 2003 to that in 2011?
Provide a short and direct response. 0.89. What is the ratio of the Education completion rate(%) of Estonia in 2003 to that in 2011?
Your answer should be compact. 0.98. What is the ratio of the Education completion rate(%) of Liechtenstein in 2003 to that in 2011?
Keep it short and to the point. 0.62. What is the ratio of the Education completion rate(%) of Low income in 2004 to that in 2006?
Offer a very short reply. 0.88. What is the ratio of the Education completion rate(%) of Middle East & North Africa (all income levels) in 2004 to that in 2006?
Provide a short and direct response. 0.98. What is the ratio of the Education completion rate(%) in Estonia in 2004 to that in 2006?
Provide a succinct answer. 0.92. What is the ratio of the Education completion rate(%) in Liechtenstein in 2004 to that in 2006?
Give a very brief answer. 1.48. What is the ratio of the Education completion rate(%) in Low income in 2004 to that in 2008?
Your answer should be compact. 0.76. What is the ratio of the Education completion rate(%) of Estonia in 2004 to that in 2008?
Give a very brief answer. 0.95. What is the ratio of the Education completion rate(%) of Liechtenstein in 2004 to that in 2008?
Provide a succinct answer. 1.06. What is the ratio of the Education completion rate(%) in Low income in 2004 to that in 2009?
Offer a very short reply. 0.72. What is the ratio of the Education completion rate(%) of Middle East & North Africa (all income levels) in 2004 to that in 2009?
Your answer should be compact. 0.93. What is the ratio of the Education completion rate(%) in Low income in 2004 to that in 2010?
Offer a very short reply. 0.68. What is the ratio of the Education completion rate(%) in Middle East & North Africa (all income levels) in 2004 to that in 2010?
Your answer should be very brief. 0.94. What is the ratio of the Education completion rate(%) in Estonia in 2004 to that in 2010?
Keep it short and to the point. 1.01. What is the ratio of the Education completion rate(%) of Liechtenstein in 2004 to that in 2010?
Provide a short and direct response. 0.81. What is the ratio of the Education completion rate(%) of Low income in 2004 to that in 2011?
Offer a terse response. 0.66. What is the ratio of the Education completion rate(%) in Middle East & North Africa (all income levels) in 2004 to that in 2011?
Provide a succinct answer. 0.9. What is the ratio of the Education completion rate(%) in Estonia in 2004 to that in 2011?
Provide a succinct answer. 1.05. What is the ratio of the Education completion rate(%) of Liechtenstein in 2004 to that in 2011?
Your answer should be very brief. 0.95. What is the ratio of the Education completion rate(%) in Low income in 2006 to that in 2008?
Give a very brief answer. 0.87. What is the ratio of the Education completion rate(%) of Middle East & North Africa (all income levels) in 2006 to that in 2008?
Make the answer very short. 0.99. What is the ratio of the Education completion rate(%) of Liechtenstein in 2006 to that in 2008?
Ensure brevity in your answer.  0.72. What is the ratio of the Education completion rate(%) of Low income in 2006 to that in 2009?
Offer a terse response. 0.82. What is the ratio of the Education completion rate(%) of Middle East & North Africa (all income levels) in 2006 to that in 2009?
Provide a succinct answer. 0.96. What is the ratio of the Education completion rate(%) in Estonia in 2006 to that in 2009?
Your answer should be very brief. 1.09. What is the ratio of the Education completion rate(%) in Liechtenstein in 2006 to that in 2009?
Your answer should be compact. 0.68. What is the ratio of the Education completion rate(%) in Low income in 2006 to that in 2010?
Provide a short and direct response. 0.78. What is the ratio of the Education completion rate(%) in Middle East & North Africa (all income levels) in 2006 to that in 2010?
Give a very brief answer. 0.96. What is the ratio of the Education completion rate(%) in Estonia in 2006 to that in 2010?
Ensure brevity in your answer.  1.1. What is the ratio of the Education completion rate(%) in Liechtenstein in 2006 to that in 2010?
Your answer should be compact. 0.55. What is the ratio of the Education completion rate(%) in Low income in 2006 to that in 2011?
Your response must be concise. 0.75. What is the ratio of the Education completion rate(%) of Middle East & North Africa (all income levels) in 2006 to that in 2011?
Keep it short and to the point. 0.93. What is the ratio of the Education completion rate(%) of Estonia in 2006 to that in 2011?
Your answer should be very brief. 1.14. What is the ratio of the Education completion rate(%) of Liechtenstein in 2006 to that in 2011?
Give a very brief answer. 0.65. What is the ratio of the Education completion rate(%) in Low income in 2008 to that in 2009?
Keep it short and to the point. 0.94. What is the ratio of the Education completion rate(%) in Middle East & North Africa (all income levels) in 2008 to that in 2009?
Your response must be concise. 0.97. What is the ratio of the Education completion rate(%) in Estonia in 2008 to that in 2009?
Offer a very short reply. 1.06. What is the ratio of the Education completion rate(%) of Liechtenstein in 2008 to that in 2009?
Offer a very short reply. 0.95. What is the ratio of the Education completion rate(%) of Low income in 2008 to that in 2010?
Ensure brevity in your answer.  0.89. What is the ratio of the Education completion rate(%) of Middle East & North Africa (all income levels) in 2008 to that in 2010?
Give a very brief answer. 0.97. What is the ratio of the Education completion rate(%) in Estonia in 2008 to that in 2010?
Ensure brevity in your answer.  1.07. What is the ratio of the Education completion rate(%) in Liechtenstein in 2008 to that in 2010?
Keep it short and to the point. 0.77. What is the ratio of the Education completion rate(%) of Low income in 2008 to that in 2011?
Offer a terse response. 0.86. What is the ratio of the Education completion rate(%) in Middle East & North Africa (all income levels) in 2008 to that in 2011?
Offer a very short reply. 0.94. What is the ratio of the Education completion rate(%) of Estonia in 2008 to that in 2011?
Make the answer very short. 1.11. What is the ratio of the Education completion rate(%) of Liechtenstein in 2008 to that in 2011?
Provide a short and direct response. 0.9. What is the ratio of the Education completion rate(%) of Low income in 2009 to that in 2010?
Your answer should be very brief. 0.95. What is the ratio of the Education completion rate(%) of Estonia in 2009 to that in 2010?
Your answer should be compact. 1.01. What is the ratio of the Education completion rate(%) of Liechtenstein in 2009 to that in 2010?
Give a very brief answer. 0.81. What is the ratio of the Education completion rate(%) of Low income in 2009 to that in 2011?
Your answer should be compact. 0.92. What is the ratio of the Education completion rate(%) of Middle East & North Africa (all income levels) in 2009 to that in 2011?
Your answer should be very brief. 0.97. What is the ratio of the Education completion rate(%) of Estonia in 2009 to that in 2011?
Make the answer very short. 1.04. What is the ratio of the Education completion rate(%) of Liechtenstein in 2009 to that in 2011?
Give a very brief answer. 0.95. What is the ratio of the Education completion rate(%) of Low income in 2010 to that in 2011?
Your response must be concise. 0.97. What is the ratio of the Education completion rate(%) of Estonia in 2010 to that in 2011?
Your response must be concise. 1.03. What is the ratio of the Education completion rate(%) in Liechtenstein in 2010 to that in 2011?
Your answer should be compact. 1.17. What is the difference between the highest and the second highest Education completion rate(%) in Low income?
Ensure brevity in your answer.  0.99. What is the difference between the highest and the second highest Education completion rate(%) in Middle East & North Africa (all income levels)?
Make the answer very short. 2.48. What is the difference between the highest and the second highest Education completion rate(%) in Estonia?
Make the answer very short. 3.24. What is the difference between the highest and the second highest Education completion rate(%) in Liechtenstein?
Offer a very short reply. 18.95. What is the difference between the highest and the lowest Education completion rate(%) in Low income?
Keep it short and to the point. 11.01. What is the difference between the highest and the lowest Education completion rate(%) in Middle East & North Africa (all income levels)?
Offer a very short reply. 8.68. What is the difference between the highest and the lowest Education completion rate(%) of Estonia?
Your answer should be very brief. 15.22. What is the difference between the highest and the lowest Education completion rate(%) in Liechtenstein?
Offer a very short reply. 60.61. 